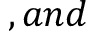Convert formula to latex. <formula><loc_0><loc_0><loc_500><loc_500>, a n d</formula> 